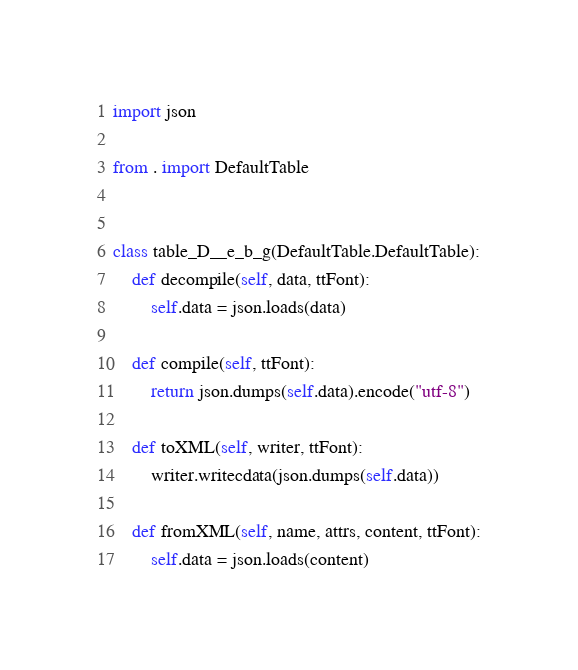Convert code to text. <code><loc_0><loc_0><loc_500><loc_500><_Python_>import json

from . import DefaultTable


class table_D__e_b_g(DefaultTable.DefaultTable):
    def decompile(self, data, ttFont):
        self.data = json.loads(data)

    def compile(self, ttFont):
        return json.dumps(self.data).encode("utf-8")

    def toXML(self, writer, ttFont):
        writer.writecdata(json.dumps(self.data))

    def fromXML(self, name, attrs, content, ttFont):
        self.data = json.loads(content)
</code> 